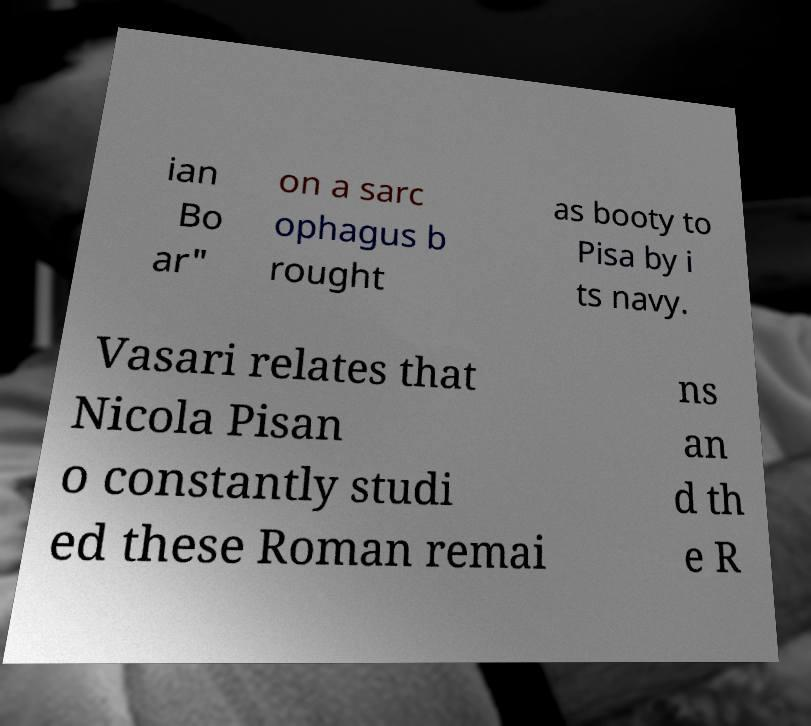For documentation purposes, I need the text within this image transcribed. Could you provide that? ian Bo ar" on a sarc ophagus b rought as booty to Pisa by i ts navy. Vasari relates that Nicola Pisan o constantly studi ed these Roman remai ns an d th e R 